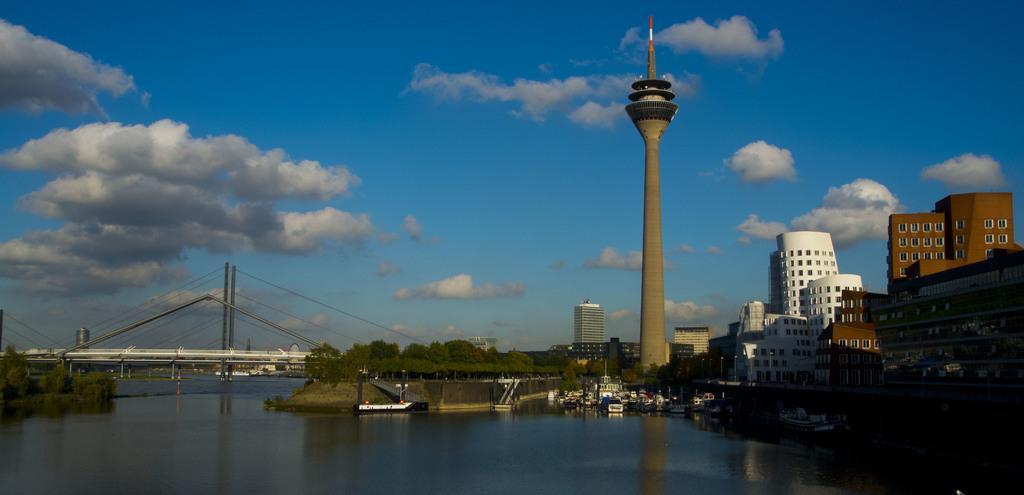How would you summarize this image in a sentence or two? In this image there is a river, in that river there are boats, on the river there is a bridge near the bridge there are trees, on the right side there are buildings and a tower, in the background there is a blue sky. 